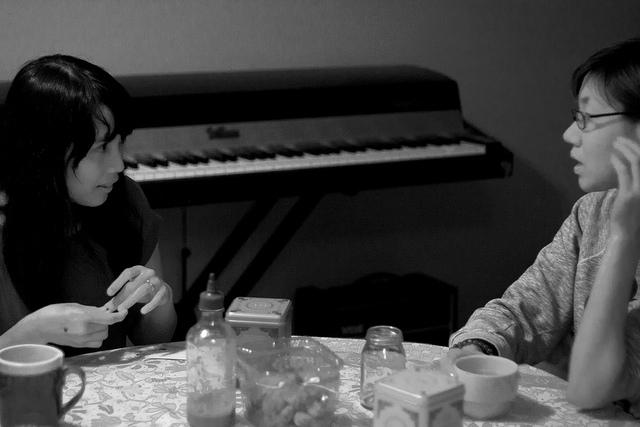What type musician lives here?

Choices:
A) violinist
B) triangle player
C) percussionist
D) pianist pianist 